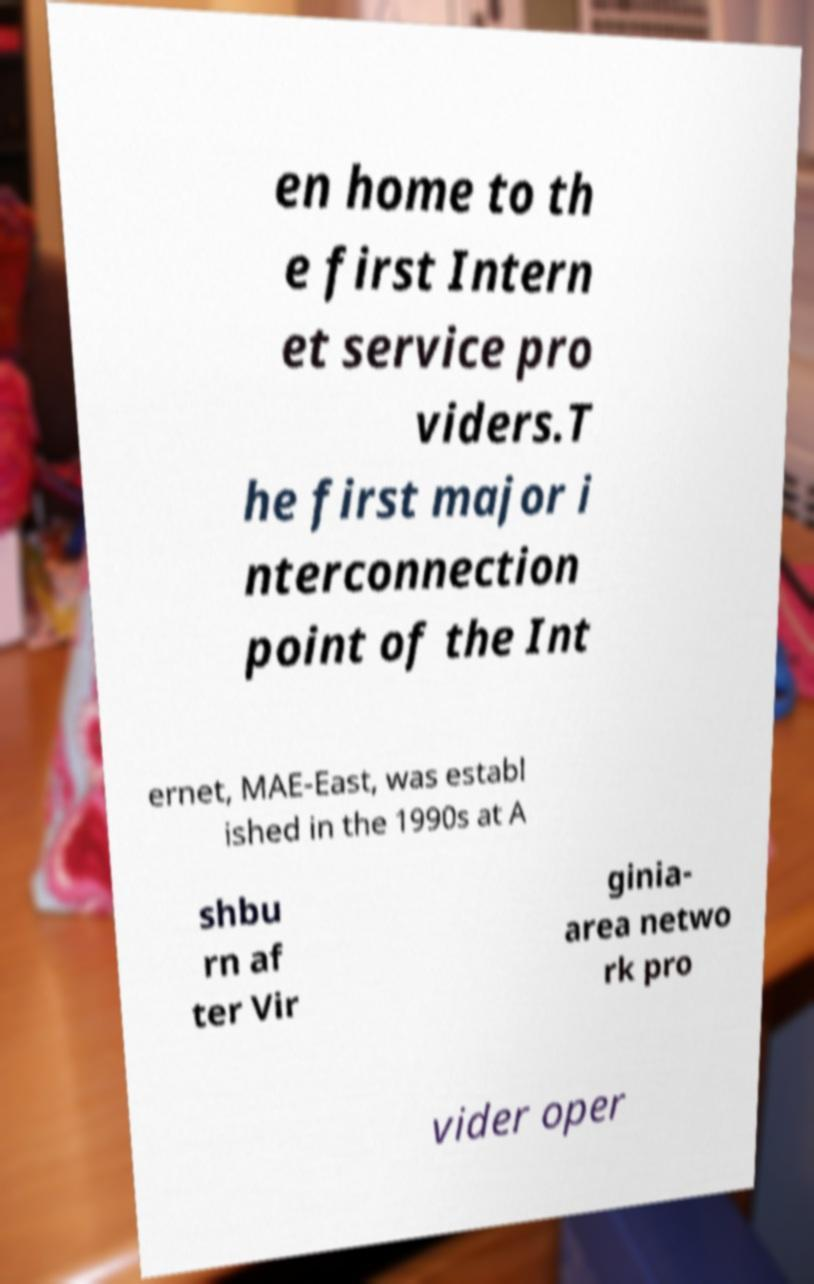Can you read and provide the text displayed in the image?This photo seems to have some interesting text. Can you extract and type it out for me? en home to th e first Intern et service pro viders.T he first major i nterconnection point of the Int ernet, MAE-East, was establ ished in the 1990s at A shbu rn af ter Vir ginia- area netwo rk pro vider oper 